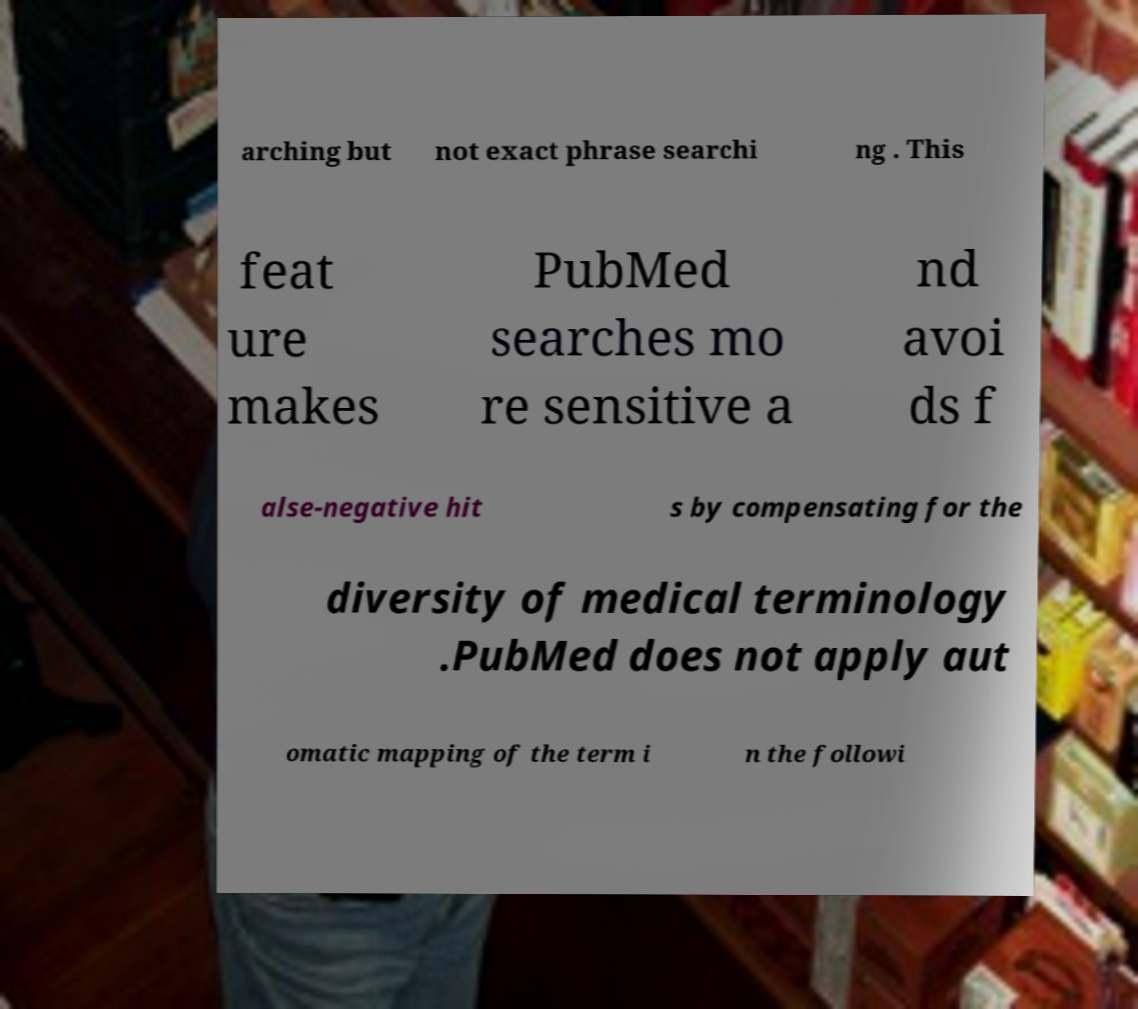Can you read and provide the text displayed in the image?This photo seems to have some interesting text. Can you extract and type it out for me? arching but not exact phrase searchi ng . This feat ure makes PubMed searches mo re sensitive a nd avoi ds f alse-negative hit s by compensating for the diversity of medical terminology .PubMed does not apply aut omatic mapping of the term i n the followi 